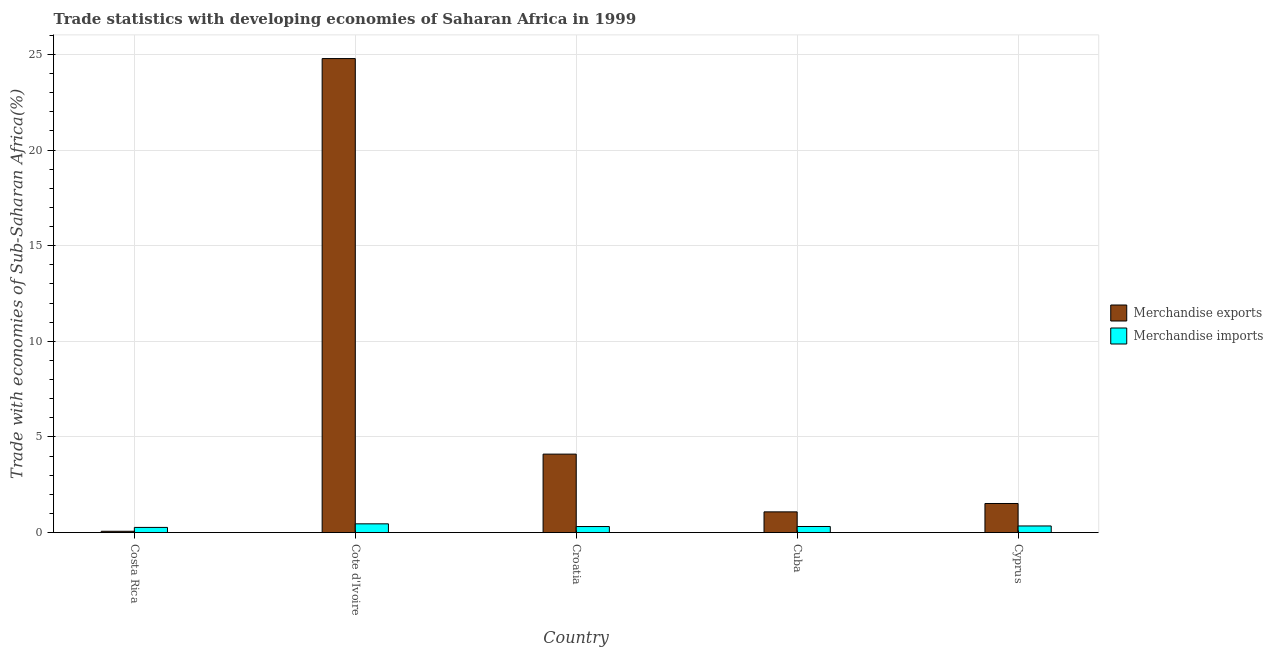Are the number of bars per tick equal to the number of legend labels?
Provide a short and direct response. Yes. How many bars are there on the 3rd tick from the left?
Your answer should be very brief. 2. What is the label of the 2nd group of bars from the left?
Ensure brevity in your answer.  Cote d'Ivoire. What is the merchandise exports in Cuba?
Make the answer very short. 1.08. Across all countries, what is the maximum merchandise imports?
Provide a succinct answer. 0.46. Across all countries, what is the minimum merchandise exports?
Your answer should be compact. 0.07. In which country was the merchandise imports maximum?
Offer a terse response. Cote d'Ivoire. What is the total merchandise exports in the graph?
Provide a succinct answer. 31.56. What is the difference between the merchandise imports in Croatia and that in Cuba?
Offer a very short reply. -0. What is the difference between the merchandise exports in Cuba and the merchandise imports in Cyprus?
Your answer should be very brief. 0.74. What is the average merchandise exports per country?
Provide a short and direct response. 6.31. What is the difference between the merchandise exports and merchandise imports in Croatia?
Give a very brief answer. 3.79. What is the ratio of the merchandise imports in Cote d'Ivoire to that in Cuba?
Give a very brief answer. 1.43. Is the merchandise exports in Cote d'Ivoire less than that in Cuba?
Your answer should be compact. No. What is the difference between the highest and the second highest merchandise imports?
Offer a very short reply. 0.11. What is the difference between the highest and the lowest merchandise exports?
Provide a succinct answer. 24.71. In how many countries, is the merchandise imports greater than the average merchandise imports taken over all countries?
Your response must be concise. 2. Is the sum of the merchandise imports in Costa Rica and Cote d'Ivoire greater than the maximum merchandise exports across all countries?
Give a very brief answer. No. What does the 2nd bar from the left in Cyprus represents?
Make the answer very short. Merchandise imports. What does the 2nd bar from the right in Costa Rica represents?
Keep it short and to the point. Merchandise exports. How many bars are there?
Provide a succinct answer. 10. How many countries are there in the graph?
Your response must be concise. 5. What is the difference between two consecutive major ticks on the Y-axis?
Offer a terse response. 5. Does the graph contain any zero values?
Give a very brief answer. No. Where does the legend appear in the graph?
Offer a very short reply. Center right. How many legend labels are there?
Keep it short and to the point. 2. How are the legend labels stacked?
Keep it short and to the point. Vertical. What is the title of the graph?
Keep it short and to the point. Trade statistics with developing economies of Saharan Africa in 1999. What is the label or title of the Y-axis?
Ensure brevity in your answer.  Trade with economies of Sub-Saharan Africa(%). What is the Trade with economies of Sub-Saharan Africa(%) in Merchandise exports in Costa Rica?
Your response must be concise. 0.07. What is the Trade with economies of Sub-Saharan Africa(%) in Merchandise imports in Costa Rica?
Your answer should be compact. 0.27. What is the Trade with economies of Sub-Saharan Africa(%) in Merchandise exports in Cote d'Ivoire?
Ensure brevity in your answer.  24.78. What is the Trade with economies of Sub-Saharan Africa(%) of Merchandise imports in Cote d'Ivoire?
Give a very brief answer. 0.46. What is the Trade with economies of Sub-Saharan Africa(%) in Merchandise exports in Croatia?
Offer a very short reply. 4.1. What is the Trade with economies of Sub-Saharan Africa(%) in Merchandise imports in Croatia?
Provide a succinct answer. 0.32. What is the Trade with economies of Sub-Saharan Africa(%) in Merchandise exports in Cuba?
Offer a very short reply. 1.08. What is the Trade with economies of Sub-Saharan Africa(%) in Merchandise imports in Cuba?
Provide a succinct answer. 0.32. What is the Trade with economies of Sub-Saharan Africa(%) of Merchandise exports in Cyprus?
Provide a succinct answer. 1.52. What is the Trade with economies of Sub-Saharan Africa(%) of Merchandise imports in Cyprus?
Provide a succinct answer. 0.35. Across all countries, what is the maximum Trade with economies of Sub-Saharan Africa(%) in Merchandise exports?
Make the answer very short. 24.78. Across all countries, what is the maximum Trade with economies of Sub-Saharan Africa(%) of Merchandise imports?
Keep it short and to the point. 0.46. Across all countries, what is the minimum Trade with economies of Sub-Saharan Africa(%) in Merchandise exports?
Provide a short and direct response. 0.07. Across all countries, what is the minimum Trade with economies of Sub-Saharan Africa(%) of Merchandise imports?
Provide a succinct answer. 0.27. What is the total Trade with economies of Sub-Saharan Africa(%) in Merchandise exports in the graph?
Make the answer very short. 31.56. What is the total Trade with economies of Sub-Saharan Africa(%) of Merchandise imports in the graph?
Offer a very short reply. 1.71. What is the difference between the Trade with economies of Sub-Saharan Africa(%) in Merchandise exports in Costa Rica and that in Cote d'Ivoire?
Offer a terse response. -24.71. What is the difference between the Trade with economies of Sub-Saharan Africa(%) of Merchandise imports in Costa Rica and that in Cote d'Ivoire?
Keep it short and to the point. -0.19. What is the difference between the Trade with economies of Sub-Saharan Africa(%) of Merchandise exports in Costa Rica and that in Croatia?
Your answer should be compact. -4.03. What is the difference between the Trade with economies of Sub-Saharan Africa(%) of Merchandise imports in Costa Rica and that in Croatia?
Offer a terse response. -0.05. What is the difference between the Trade with economies of Sub-Saharan Africa(%) of Merchandise exports in Costa Rica and that in Cuba?
Provide a short and direct response. -1.01. What is the difference between the Trade with economies of Sub-Saharan Africa(%) of Merchandise imports in Costa Rica and that in Cuba?
Offer a very short reply. -0.05. What is the difference between the Trade with economies of Sub-Saharan Africa(%) of Merchandise exports in Costa Rica and that in Cyprus?
Keep it short and to the point. -1.45. What is the difference between the Trade with economies of Sub-Saharan Africa(%) in Merchandise imports in Costa Rica and that in Cyprus?
Offer a very short reply. -0.08. What is the difference between the Trade with economies of Sub-Saharan Africa(%) of Merchandise exports in Cote d'Ivoire and that in Croatia?
Ensure brevity in your answer.  20.68. What is the difference between the Trade with economies of Sub-Saharan Africa(%) in Merchandise imports in Cote d'Ivoire and that in Croatia?
Your answer should be very brief. 0.14. What is the difference between the Trade with economies of Sub-Saharan Africa(%) in Merchandise exports in Cote d'Ivoire and that in Cuba?
Offer a very short reply. 23.7. What is the difference between the Trade with economies of Sub-Saharan Africa(%) of Merchandise imports in Cote d'Ivoire and that in Cuba?
Ensure brevity in your answer.  0.14. What is the difference between the Trade with economies of Sub-Saharan Africa(%) of Merchandise exports in Cote d'Ivoire and that in Cyprus?
Make the answer very short. 23.26. What is the difference between the Trade with economies of Sub-Saharan Africa(%) in Merchandise imports in Cote d'Ivoire and that in Cyprus?
Keep it short and to the point. 0.11. What is the difference between the Trade with economies of Sub-Saharan Africa(%) of Merchandise exports in Croatia and that in Cuba?
Make the answer very short. 3.02. What is the difference between the Trade with economies of Sub-Saharan Africa(%) of Merchandise imports in Croatia and that in Cuba?
Ensure brevity in your answer.  -0. What is the difference between the Trade with economies of Sub-Saharan Africa(%) of Merchandise exports in Croatia and that in Cyprus?
Provide a short and direct response. 2.58. What is the difference between the Trade with economies of Sub-Saharan Africa(%) in Merchandise imports in Croatia and that in Cyprus?
Your response must be concise. -0.03. What is the difference between the Trade with economies of Sub-Saharan Africa(%) in Merchandise exports in Cuba and that in Cyprus?
Your answer should be compact. -0.44. What is the difference between the Trade with economies of Sub-Saharan Africa(%) in Merchandise imports in Cuba and that in Cyprus?
Provide a succinct answer. -0.03. What is the difference between the Trade with economies of Sub-Saharan Africa(%) of Merchandise exports in Costa Rica and the Trade with economies of Sub-Saharan Africa(%) of Merchandise imports in Cote d'Ivoire?
Your response must be concise. -0.39. What is the difference between the Trade with economies of Sub-Saharan Africa(%) of Merchandise exports in Costa Rica and the Trade with economies of Sub-Saharan Africa(%) of Merchandise imports in Croatia?
Your response must be concise. -0.25. What is the difference between the Trade with economies of Sub-Saharan Africa(%) in Merchandise exports in Costa Rica and the Trade with economies of Sub-Saharan Africa(%) in Merchandise imports in Cuba?
Ensure brevity in your answer.  -0.25. What is the difference between the Trade with economies of Sub-Saharan Africa(%) of Merchandise exports in Costa Rica and the Trade with economies of Sub-Saharan Africa(%) of Merchandise imports in Cyprus?
Your response must be concise. -0.28. What is the difference between the Trade with economies of Sub-Saharan Africa(%) in Merchandise exports in Cote d'Ivoire and the Trade with economies of Sub-Saharan Africa(%) in Merchandise imports in Croatia?
Offer a very short reply. 24.46. What is the difference between the Trade with economies of Sub-Saharan Africa(%) of Merchandise exports in Cote d'Ivoire and the Trade with economies of Sub-Saharan Africa(%) of Merchandise imports in Cuba?
Provide a succinct answer. 24.46. What is the difference between the Trade with economies of Sub-Saharan Africa(%) in Merchandise exports in Cote d'Ivoire and the Trade with economies of Sub-Saharan Africa(%) in Merchandise imports in Cyprus?
Make the answer very short. 24.43. What is the difference between the Trade with economies of Sub-Saharan Africa(%) in Merchandise exports in Croatia and the Trade with economies of Sub-Saharan Africa(%) in Merchandise imports in Cuba?
Your answer should be very brief. 3.78. What is the difference between the Trade with economies of Sub-Saharan Africa(%) in Merchandise exports in Croatia and the Trade with economies of Sub-Saharan Africa(%) in Merchandise imports in Cyprus?
Keep it short and to the point. 3.76. What is the difference between the Trade with economies of Sub-Saharan Africa(%) of Merchandise exports in Cuba and the Trade with economies of Sub-Saharan Africa(%) of Merchandise imports in Cyprus?
Ensure brevity in your answer.  0.74. What is the average Trade with economies of Sub-Saharan Africa(%) of Merchandise exports per country?
Your answer should be compact. 6.31. What is the average Trade with economies of Sub-Saharan Africa(%) in Merchandise imports per country?
Ensure brevity in your answer.  0.34. What is the difference between the Trade with economies of Sub-Saharan Africa(%) in Merchandise exports and Trade with economies of Sub-Saharan Africa(%) in Merchandise imports in Costa Rica?
Offer a terse response. -0.2. What is the difference between the Trade with economies of Sub-Saharan Africa(%) in Merchandise exports and Trade with economies of Sub-Saharan Africa(%) in Merchandise imports in Cote d'Ivoire?
Make the answer very short. 24.32. What is the difference between the Trade with economies of Sub-Saharan Africa(%) in Merchandise exports and Trade with economies of Sub-Saharan Africa(%) in Merchandise imports in Croatia?
Offer a very short reply. 3.79. What is the difference between the Trade with economies of Sub-Saharan Africa(%) in Merchandise exports and Trade with economies of Sub-Saharan Africa(%) in Merchandise imports in Cuba?
Your answer should be compact. 0.76. What is the difference between the Trade with economies of Sub-Saharan Africa(%) in Merchandise exports and Trade with economies of Sub-Saharan Africa(%) in Merchandise imports in Cyprus?
Provide a succinct answer. 1.17. What is the ratio of the Trade with economies of Sub-Saharan Africa(%) of Merchandise exports in Costa Rica to that in Cote d'Ivoire?
Offer a very short reply. 0. What is the ratio of the Trade with economies of Sub-Saharan Africa(%) in Merchandise imports in Costa Rica to that in Cote d'Ivoire?
Make the answer very short. 0.59. What is the ratio of the Trade with economies of Sub-Saharan Africa(%) of Merchandise exports in Costa Rica to that in Croatia?
Provide a short and direct response. 0.02. What is the ratio of the Trade with economies of Sub-Saharan Africa(%) of Merchandise imports in Costa Rica to that in Croatia?
Give a very brief answer. 0.85. What is the ratio of the Trade with economies of Sub-Saharan Africa(%) in Merchandise exports in Costa Rica to that in Cuba?
Provide a short and direct response. 0.06. What is the ratio of the Trade with economies of Sub-Saharan Africa(%) in Merchandise imports in Costa Rica to that in Cuba?
Provide a short and direct response. 0.85. What is the ratio of the Trade with economies of Sub-Saharan Africa(%) of Merchandise exports in Costa Rica to that in Cyprus?
Your answer should be very brief. 0.05. What is the ratio of the Trade with economies of Sub-Saharan Africa(%) of Merchandise imports in Costa Rica to that in Cyprus?
Offer a terse response. 0.78. What is the ratio of the Trade with economies of Sub-Saharan Africa(%) of Merchandise exports in Cote d'Ivoire to that in Croatia?
Make the answer very short. 6.04. What is the ratio of the Trade with economies of Sub-Saharan Africa(%) of Merchandise imports in Cote d'Ivoire to that in Croatia?
Make the answer very short. 1.44. What is the ratio of the Trade with economies of Sub-Saharan Africa(%) of Merchandise exports in Cote d'Ivoire to that in Cuba?
Your answer should be compact. 22.87. What is the ratio of the Trade with economies of Sub-Saharan Africa(%) in Merchandise imports in Cote d'Ivoire to that in Cuba?
Your answer should be compact. 1.43. What is the ratio of the Trade with economies of Sub-Saharan Africa(%) of Merchandise exports in Cote d'Ivoire to that in Cyprus?
Your answer should be very brief. 16.29. What is the ratio of the Trade with economies of Sub-Saharan Africa(%) of Merchandise imports in Cote d'Ivoire to that in Cyprus?
Your answer should be very brief. 1.32. What is the ratio of the Trade with economies of Sub-Saharan Africa(%) in Merchandise exports in Croatia to that in Cuba?
Your answer should be compact. 3.79. What is the ratio of the Trade with economies of Sub-Saharan Africa(%) of Merchandise exports in Croatia to that in Cyprus?
Offer a terse response. 2.7. What is the ratio of the Trade with economies of Sub-Saharan Africa(%) in Merchandise imports in Croatia to that in Cyprus?
Offer a very short reply. 0.91. What is the ratio of the Trade with economies of Sub-Saharan Africa(%) in Merchandise exports in Cuba to that in Cyprus?
Provide a succinct answer. 0.71. What is the ratio of the Trade with economies of Sub-Saharan Africa(%) of Merchandise imports in Cuba to that in Cyprus?
Ensure brevity in your answer.  0.92. What is the difference between the highest and the second highest Trade with economies of Sub-Saharan Africa(%) in Merchandise exports?
Your answer should be compact. 20.68. What is the difference between the highest and the second highest Trade with economies of Sub-Saharan Africa(%) of Merchandise imports?
Provide a succinct answer. 0.11. What is the difference between the highest and the lowest Trade with economies of Sub-Saharan Africa(%) in Merchandise exports?
Ensure brevity in your answer.  24.71. What is the difference between the highest and the lowest Trade with economies of Sub-Saharan Africa(%) of Merchandise imports?
Keep it short and to the point. 0.19. 